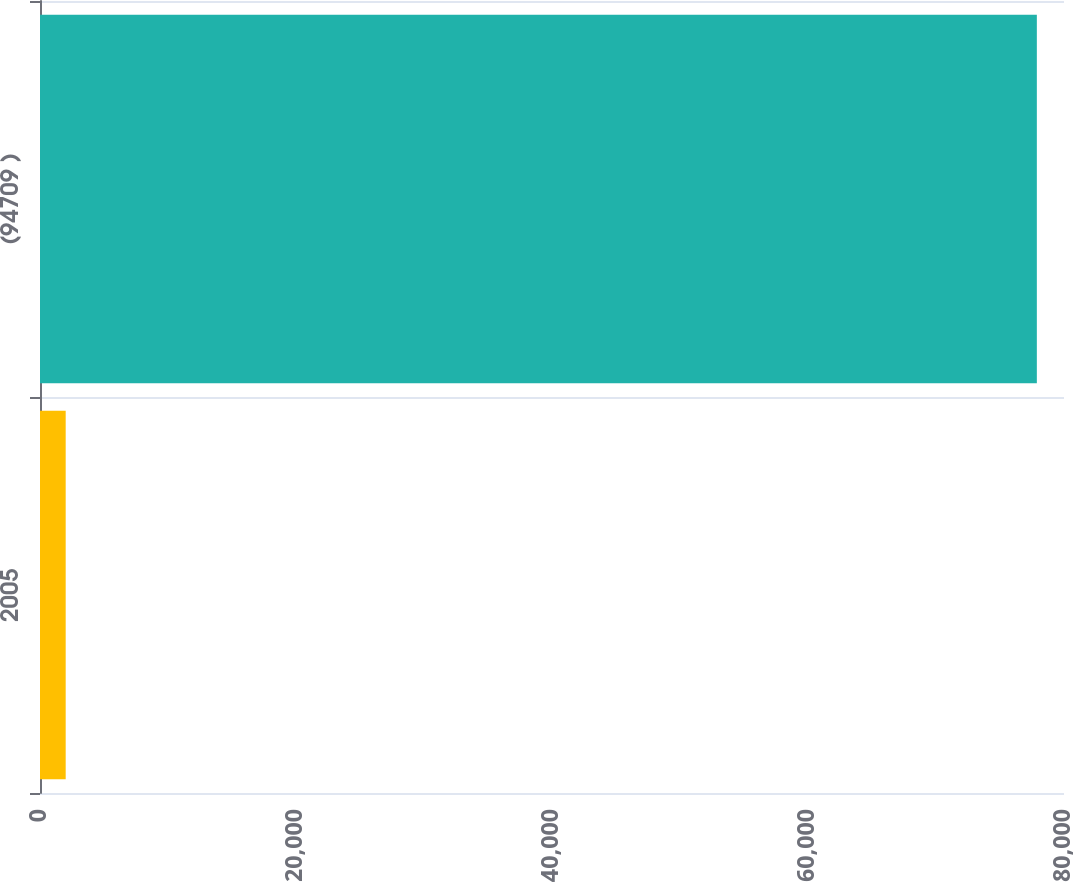Convert chart to OTSL. <chart><loc_0><loc_0><loc_500><loc_500><bar_chart><fcel>2005<fcel>(94709 )<nl><fcel>2007<fcel>77879<nl></chart> 